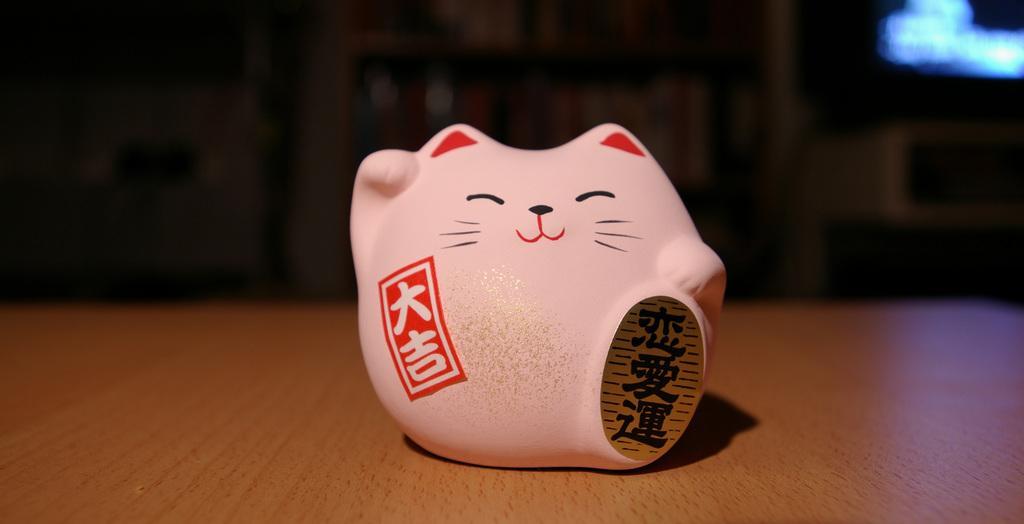How would you summarize this image in a sentence or two? In this image I can see a pink colored object which is on the brown colored surface. I can see a red colored stamp on it and a gold and black colored badge attached to it. I can see the blurry background. 